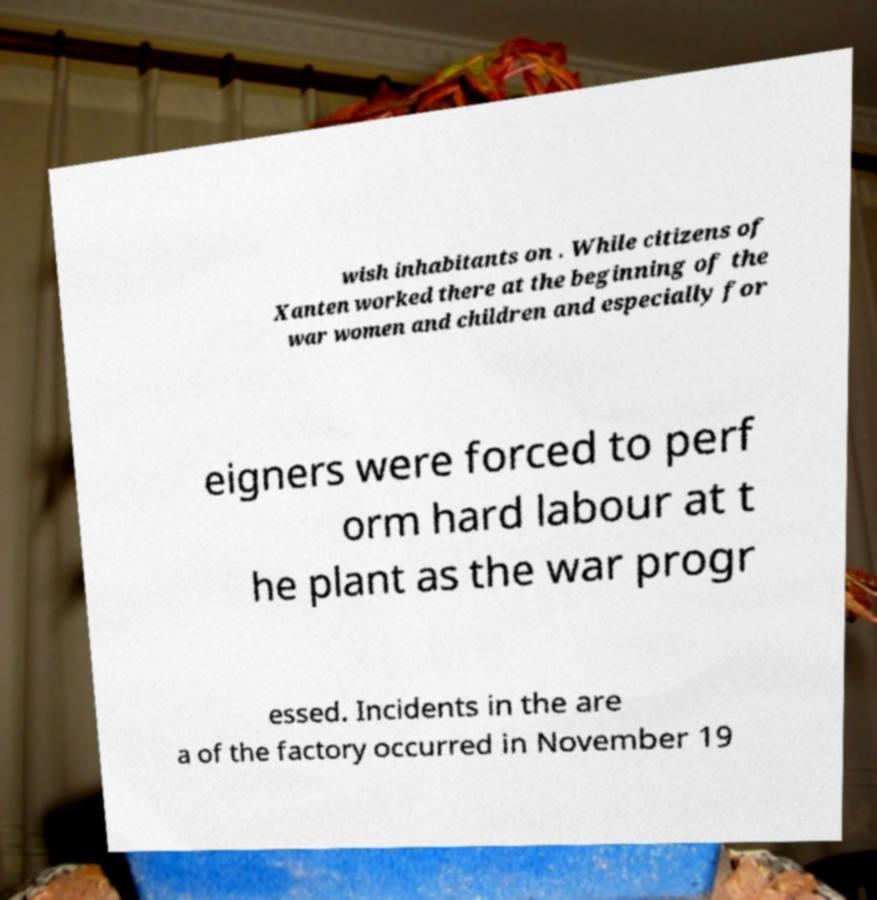Please identify and transcribe the text found in this image. wish inhabitants on . While citizens of Xanten worked there at the beginning of the war women and children and especially for eigners were forced to perf orm hard labour at t he plant as the war progr essed. Incidents in the are a of the factory occurred in November 19 